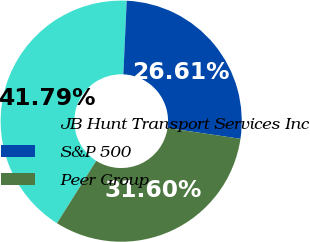Convert chart to OTSL. <chart><loc_0><loc_0><loc_500><loc_500><pie_chart><fcel>JB Hunt Transport Services Inc<fcel>S&P 500<fcel>Peer Group<nl><fcel>41.79%<fcel>26.61%<fcel>31.6%<nl></chart> 